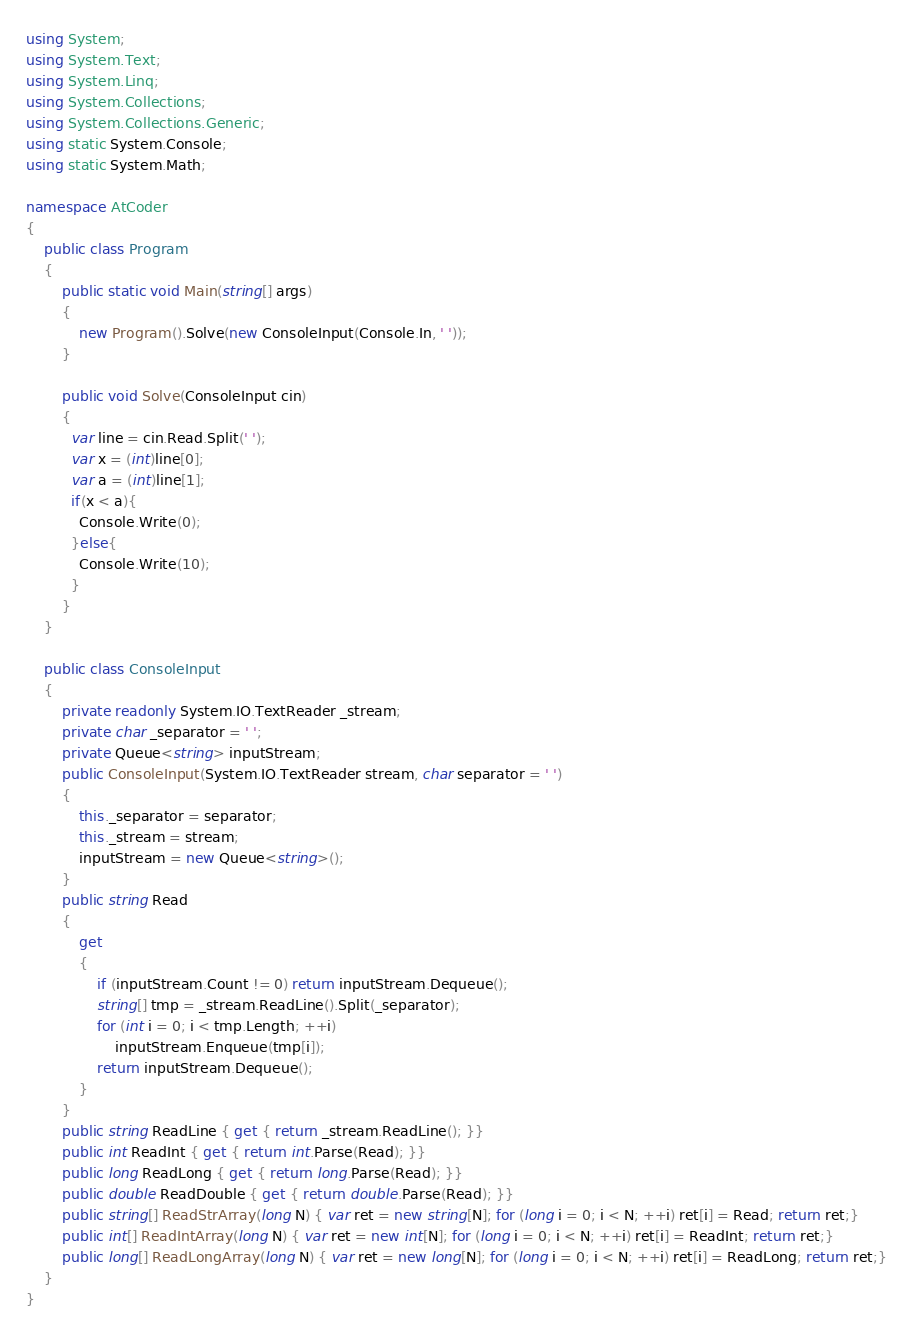<code> <loc_0><loc_0><loc_500><loc_500><_C#_>using System;
using System.Text;
using System.Linq;
using System.Collections;
using System.Collections.Generic;
using static System.Console;
using static System.Math;

namespace AtCoder
{
    public class Program
    {
        public static void Main(string[] args)
        {
            new Program().Solve(new ConsoleInput(Console.In, ' '));
        }

        public void Solve(ConsoleInput cin)
        {
          var line = cin.Read.Split(' ');
          var x = (int)line[0];
          var a = (int)line[1];
          if(x < a){
            Console.Write(0);
          }else{
            Console.Write(10);
          }
        }
    }

    public class ConsoleInput
    {
        private readonly System.IO.TextReader _stream;
        private char _separator = ' ';
        private Queue<string> inputStream;
        public ConsoleInput(System.IO.TextReader stream, char separator = ' ')
        {
            this._separator = separator;
            this._stream = stream;
            inputStream = new Queue<string>();
        }
        public string Read
        {
            get
            {
                if (inputStream.Count != 0) return inputStream.Dequeue();
                string[] tmp = _stream.ReadLine().Split(_separator);
                for (int i = 0; i < tmp.Length; ++i)
                    inputStream.Enqueue(tmp[i]);
                return inputStream.Dequeue();
            }
        }
        public string ReadLine { get { return _stream.ReadLine(); }}
        public int ReadInt { get { return int.Parse(Read); }}
        public long ReadLong { get { return long.Parse(Read); }}
        public double ReadDouble { get { return double.Parse(Read); }}
        public string[] ReadStrArray(long N) { var ret = new string[N]; for (long i = 0; i < N; ++i) ret[i] = Read; return ret;}
        public int[] ReadIntArray(long N) { var ret = new int[N]; for (long i = 0; i < N; ++i) ret[i] = ReadInt; return ret;}
        public long[] ReadLongArray(long N) { var ret = new long[N]; for (long i = 0; i < N; ++i) ret[i] = ReadLong; return ret;}
    }
}
</code> 